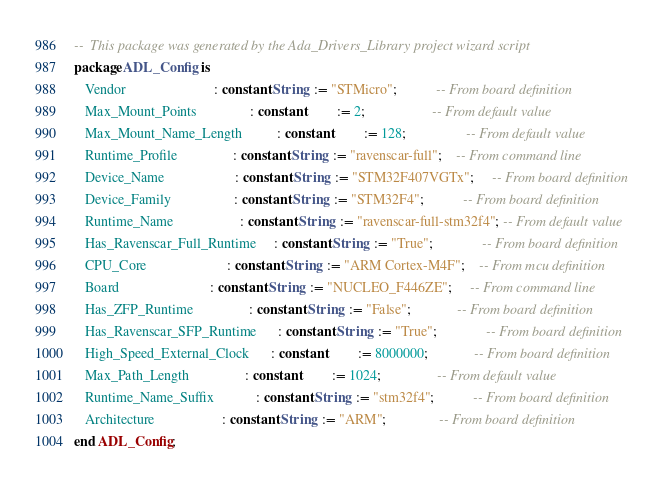<code> <loc_0><loc_0><loc_500><loc_500><_Ada_>--  This package was generated by the Ada_Drivers_Library project wizard script
package ADL_Config is
   Vendor                         : constant String  := "STMicro";           -- From board definition
   Max_Mount_Points               : constant         := 2;                   -- From default value
   Max_Mount_Name_Length          : constant         := 128;                 -- From default value
   Runtime_Profile                : constant String  := "ravenscar-full";    -- From command line
   Device_Name                    : constant String  := "STM32F407VGTx";     -- From board definition
   Device_Family                  : constant String  := "STM32F4";           -- From board definition
   Runtime_Name                   : constant String  := "ravenscar-full-stm32f4"; -- From default value
   Has_Ravenscar_Full_Runtime     : constant String  := "True";              -- From board definition
   CPU_Core                       : constant String  := "ARM Cortex-M4F";    -- From mcu definition
   Board                          : constant String  := "NUCLEO_F446ZE";     -- From command line
   Has_ZFP_Runtime                : constant String  := "False";             -- From board definition
   Has_Ravenscar_SFP_Runtime      : constant String  := "True";              -- From board definition
   High_Speed_External_Clock      : constant         := 8000000;             -- From board definition
   Max_Path_Length                : constant         := 1024;                -- From default value
   Runtime_Name_Suffix            : constant String  := "stm32f4";           -- From board definition
   Architecture                   : constant String  := "ARM";               -- From board definition
end ADL_Config;
</code> 